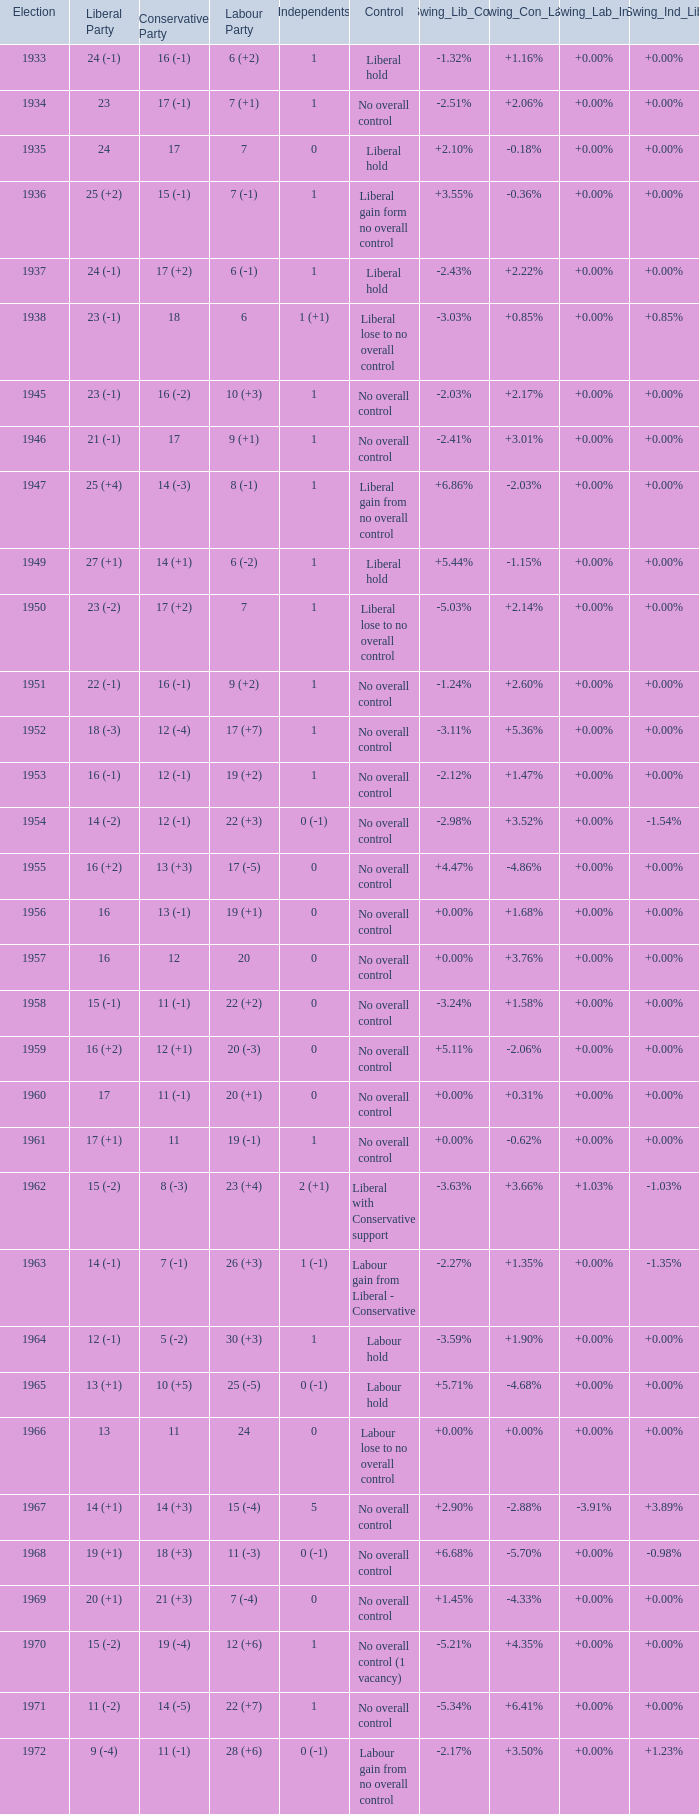What was the control for the year with a Conservative Party result of 10 (+5)? Labour hold. 